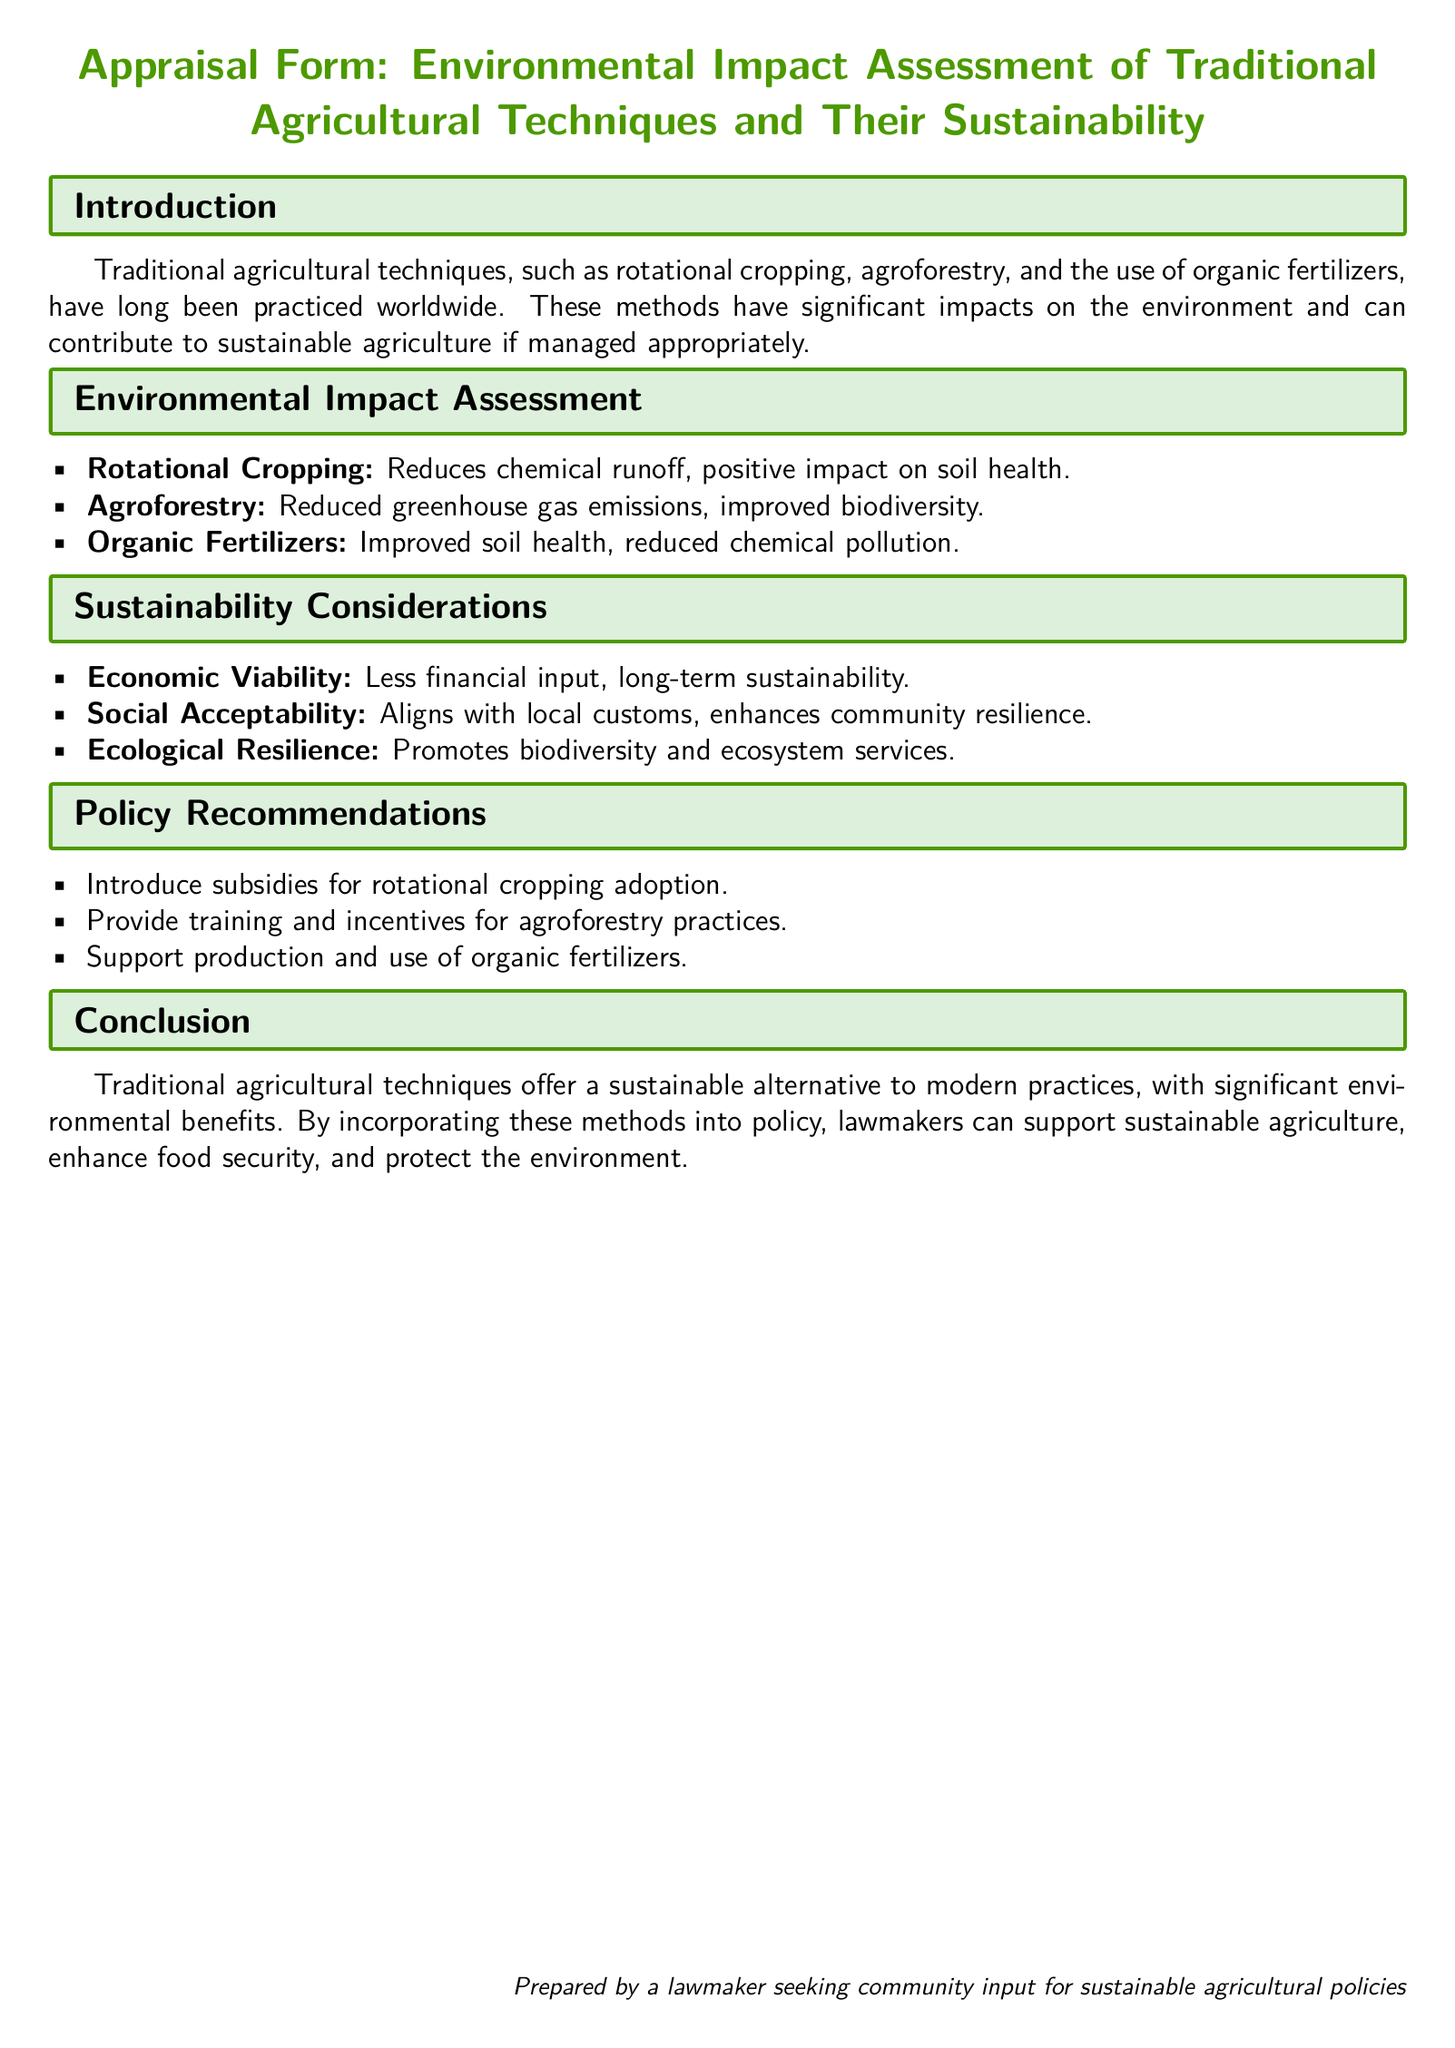What are traditional agricultural techniques? Traditional agricultural techniques include methods such as rotational cropping, agroforestry, and the use of organic fertilizers.
Answer: Rotational cropping, agroforestry, organic fertilizers What is the positive impact of rotational cropping? Rotational cropping reduces chemical runoff and has a positive impact on soil health.
Answer: Reduces chemical runoff, positive impact on soil health What recommendation is made for agroforestry practices? The document recommends providing training and incentives for adopting agroforestry practices.
Answer: Provide training and incentives What is the financial impact of traditional agricultural techniques? Traditional agricultural techniques have less financial input and promote long-term sustainability.
Answer: Less financial input, long-term sustainability What environmental benefit is associated with agroforestry? Agroforestry is associated with reduced greenhouse gas emissions and improved biodiversity.
Answer: Reduced greenhouse gas emissions, improved biodiversity How does the document describe the social acceptance of traditional agriculture? It aligns with local customs and enhances community resilience.
Answer: Aligns with local customs, enhances community resilience What is one policy recommendation related to organic fertilizers? Support production and use of organic fertilizers is one of the policy recommendations.
Answer: Support production and use of organic fertilizers What is the conclusion regarding traditional agricultural techniques? The conclusion states that these techniques offer a sustainable alternative with significant environmental benefits.
Answer: Sustainable alternative, significant environmental benefits What is the purpose of this appraisal form? The purpose is to seek community input for sustainable agricultural policies.
Answer: Seek community input for sustainable agricultural policies 